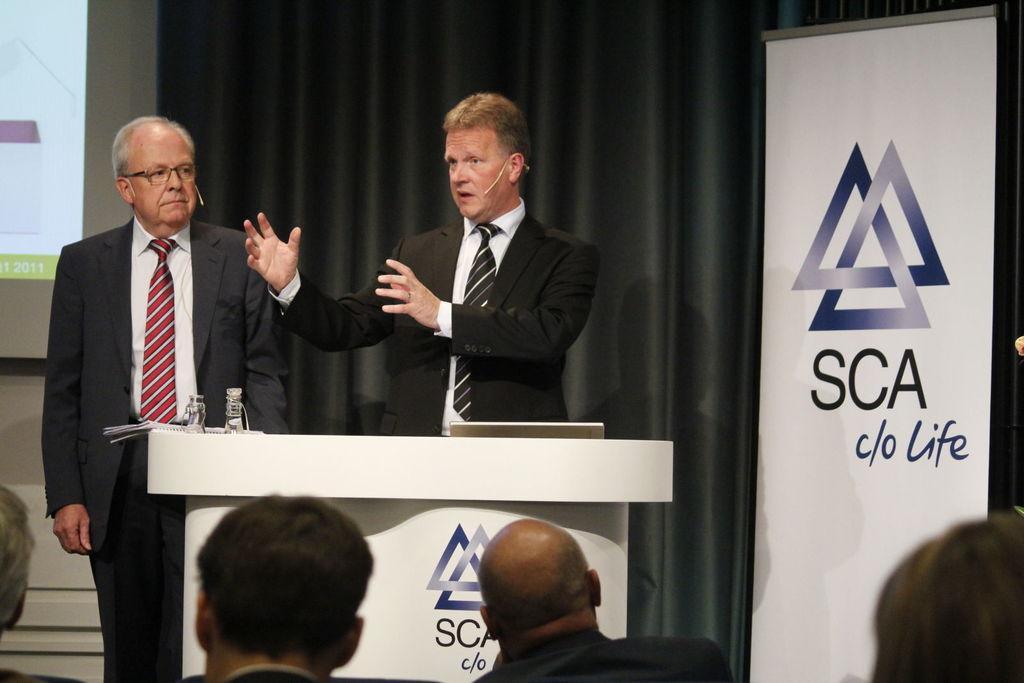How would you summarize this image in a sentence or two? In this image there are two persons standing and one person is talking, and they are wearing mike's. At the bottom there are some persons and in the center there is a podium, on the podium there are some bottles and papers. In the background there is s screen curtain and board, on the board there is some text. 